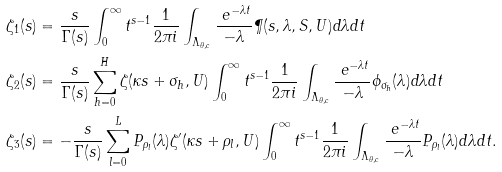<formula> <loc_0><loc_0><loc_500><loc_500>\zeta _ { 1 } ( s ) & = \frac { s } { \Gamma ( s ) } \int _ { 0 } ^ { \infty } t ^ { s - 1 } \frac { 1 } { 2 \pi i } \int _ { \Lambda _ { \theta , c } } \frac { \ e ^ { - \lambda t } } { - \lambda } \P ( s , \lambda , S , U ) d \lambda d t \\ \zeta _ { 2 } ( s ) & = \frac { s } { \Gamma ( s ) } \sum _ { h = 0 } ^ { H } \zeta ( \kappa s + \sigma _ { h } , U ) \int _ { 0 } ^ { \infty } t ^ { s - 1 } \frac { 1 } { 2 \pi i } \int _ { \Lambda _ { \theta , c } } \frac { \ e ^ { - \lambda t } } { - \lambda } \phi _ { \sigma _ { h } } ( \lambda ) d \lambda d t \\ \zeta _ { 3 } ( s ) & = - \frac { s } { \Gamma ( s ) } \sum _ { l = 0 } ^ { L } P _ { \rho _ { l } } ( \lambda ) \zeta ^ { \prime } ( \kappa s + \rho _ { l } , U ) \int _ { 0 } ^ { \infty } t ^ { s - 1 } \frac { 1 } { 2 \pi i } \int _ { \Lambda _ { \theta , c } } \frac { \ e ^ { - \lambda t } } { - \lambda } P _ { \rho _ { l } } ( \lambda ) d \lambda d t .</formula> 